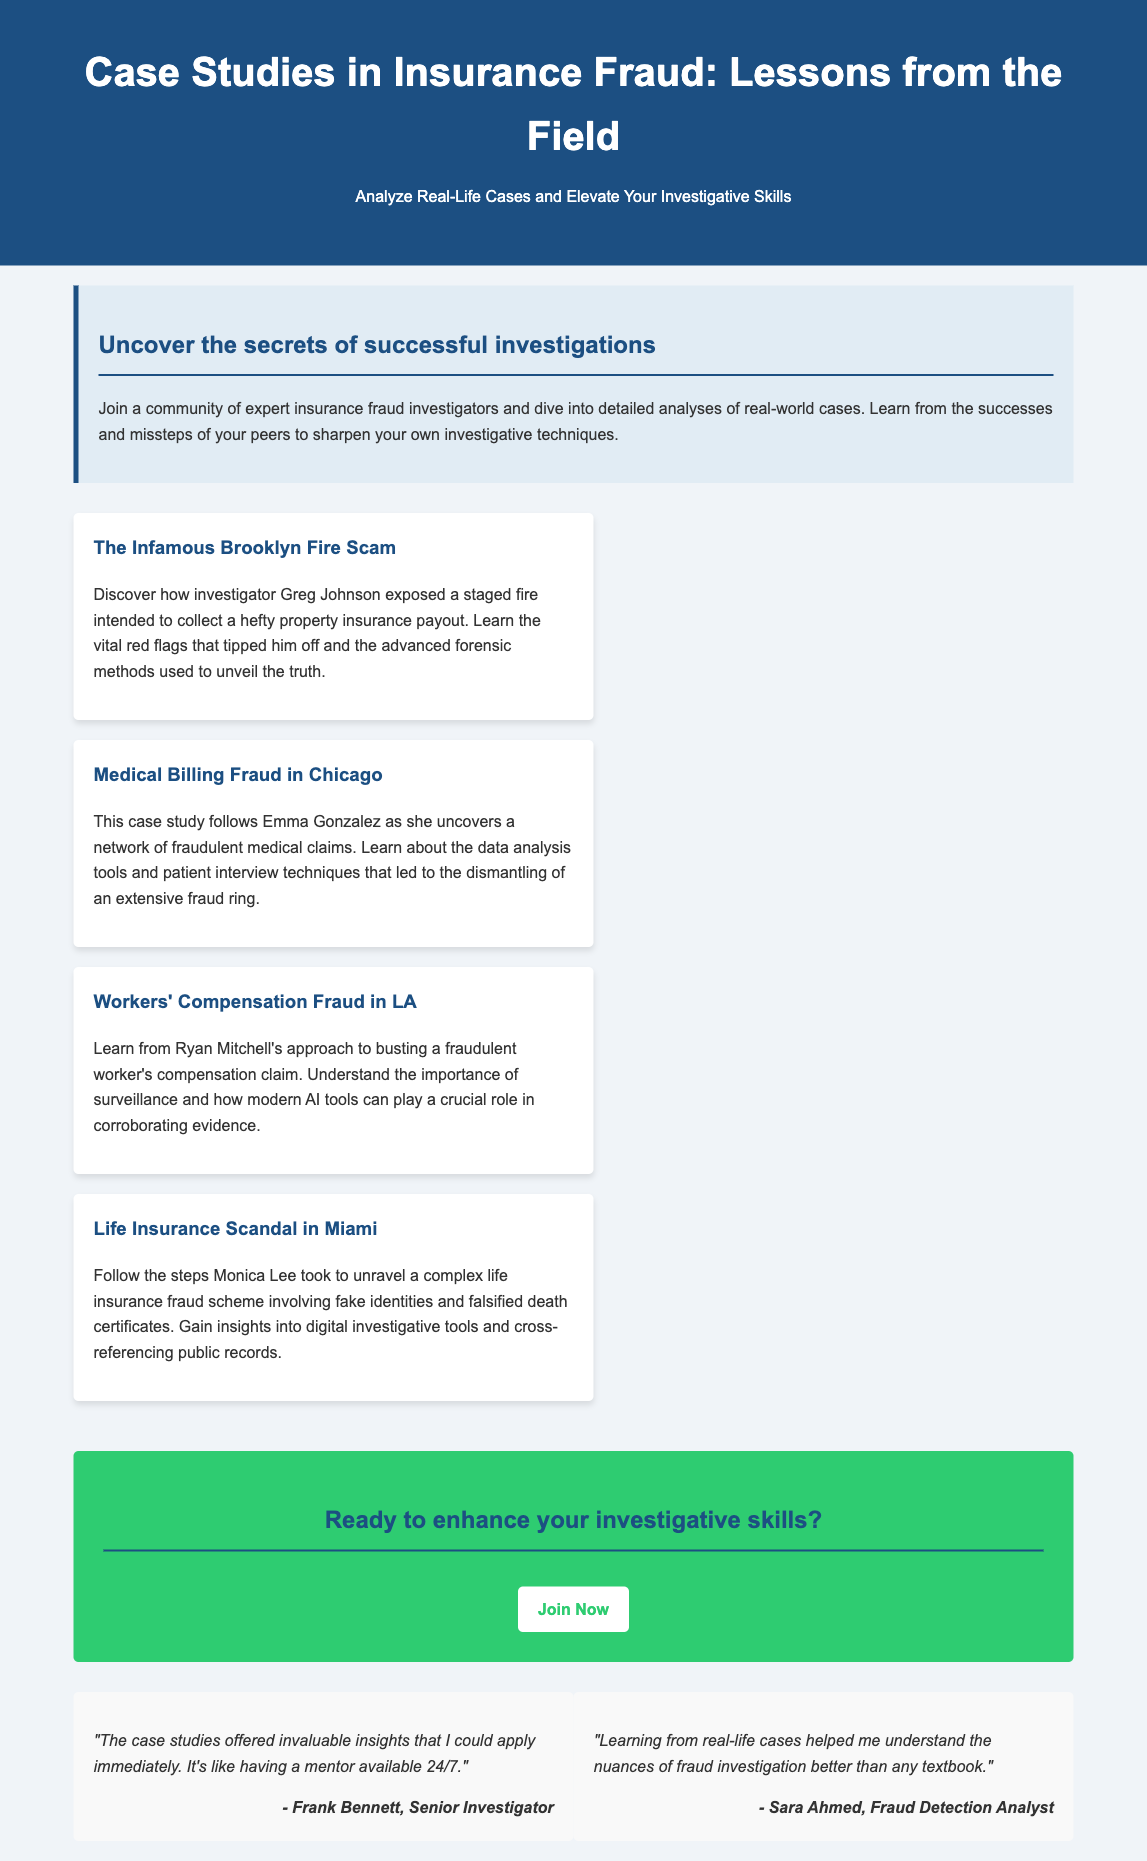What is the title of the document? The title is presented prominently at the top of the document in a large font.
Answer: Case Studies in Insurance Fraud: Lessons from the Field Who is the investigator featured in the Brooklyn fire scam case? The document mentions the investigator's name as part of the discussion for the specific case study.
Answer: Greg Johnson What case study involves a network of fraudulent medical claims? The document lists various case studies, one specifically focuses on medical billing fraud in Chicago.
Answer: Medical Billing Fraud in Chicago What essential technique was highlighted in the Workers' Compensation Fraud case? The details mention a specific method used by the investigator to gather evidence in this case.
Answer: Surveillance Which city is associated with the life insurance fraud scandal? The document explicitly names the city relevant to that specific case study.
Answer: Miami What is the call to action presented in the document? The ending section encourages readers to take a specific action.
Answer: Join Now How many case studies are summarized in the document? The structure of the document lists distinct cases related to insurance fraud.
Answer: Four 